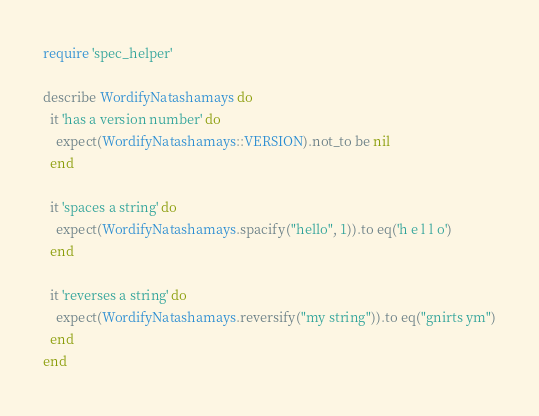Convert code to text. <code><loc_0><loc_0><loc_500><loc_500><_Ruby_>require 'spec_helper'

describe WordifyNatashamays do
  it 'has a version number' do
    expect(WordifyNatashamays::VERSION).not_to be nil
  end

  it 'spaces a string' do
    expect(WordifyNatashamays.spacify("hello", 1)).to eq('h e l l o')
  end

  it 'reverses a string' do
    expect(WordifyNatashamays.reversify("my string")).to eq("gnirts ym")
  end
end
</code> 